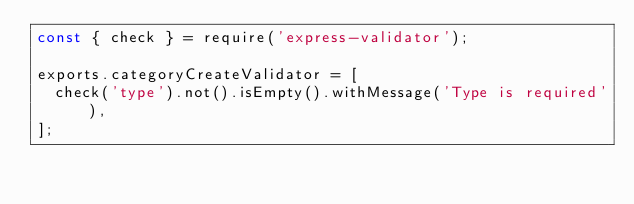Convert code to text. <code><loc_0><loc_0><loc_500><loc_500><_JavaScript_>const { check } = require('express-validator');

exports.categoryCreateValidator = [
  check('type').not().isEmpty().withMessage('Type is required'),
];
</code> 